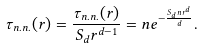Convert formula to latex. <formula><loc_0><loc_0><loc_500><loc_500>\tau _ { n . n . } ( { r } ) = \frac { \tau _ { n . n . } ( { r } ) } { S _ { d } r ^ { d - 1 } } = n e ^ { - \frac { S _ { d } n r ^ { d } } { d } } .</formula> 